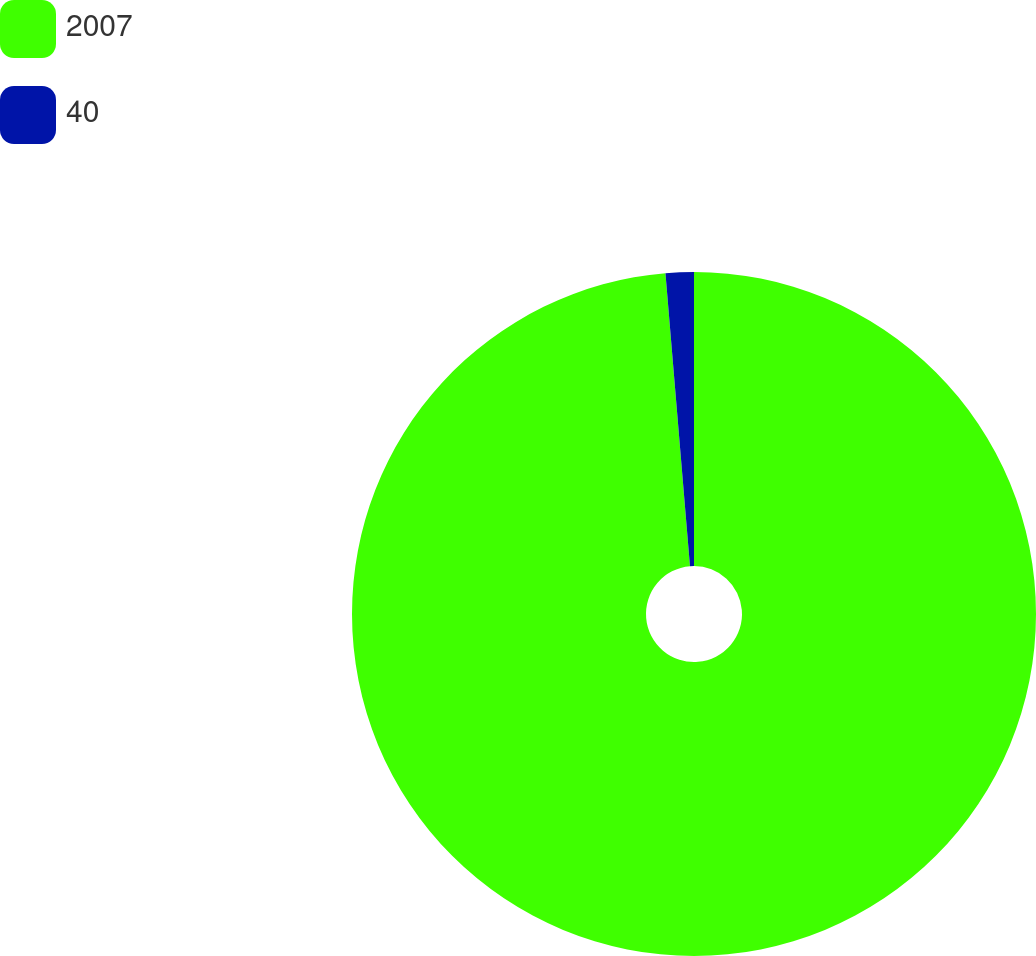Convert chart. <chart><loc_0><loc_0><loc_500><loc_500><pie_chart><fcel>2007<fcel>40<nl><fcel>98.67%<fcel>1.33%<nl></chart> 